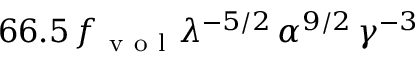<formula> <loc_0><loc_0><loc_500><loc_500>6 6 . 5 \, f _ { v o l } \lambda ^ { - 5 / 2 } \, \alpha ^ { 9 / 2 } \, \gamma ^ { - 3 }</formula> 